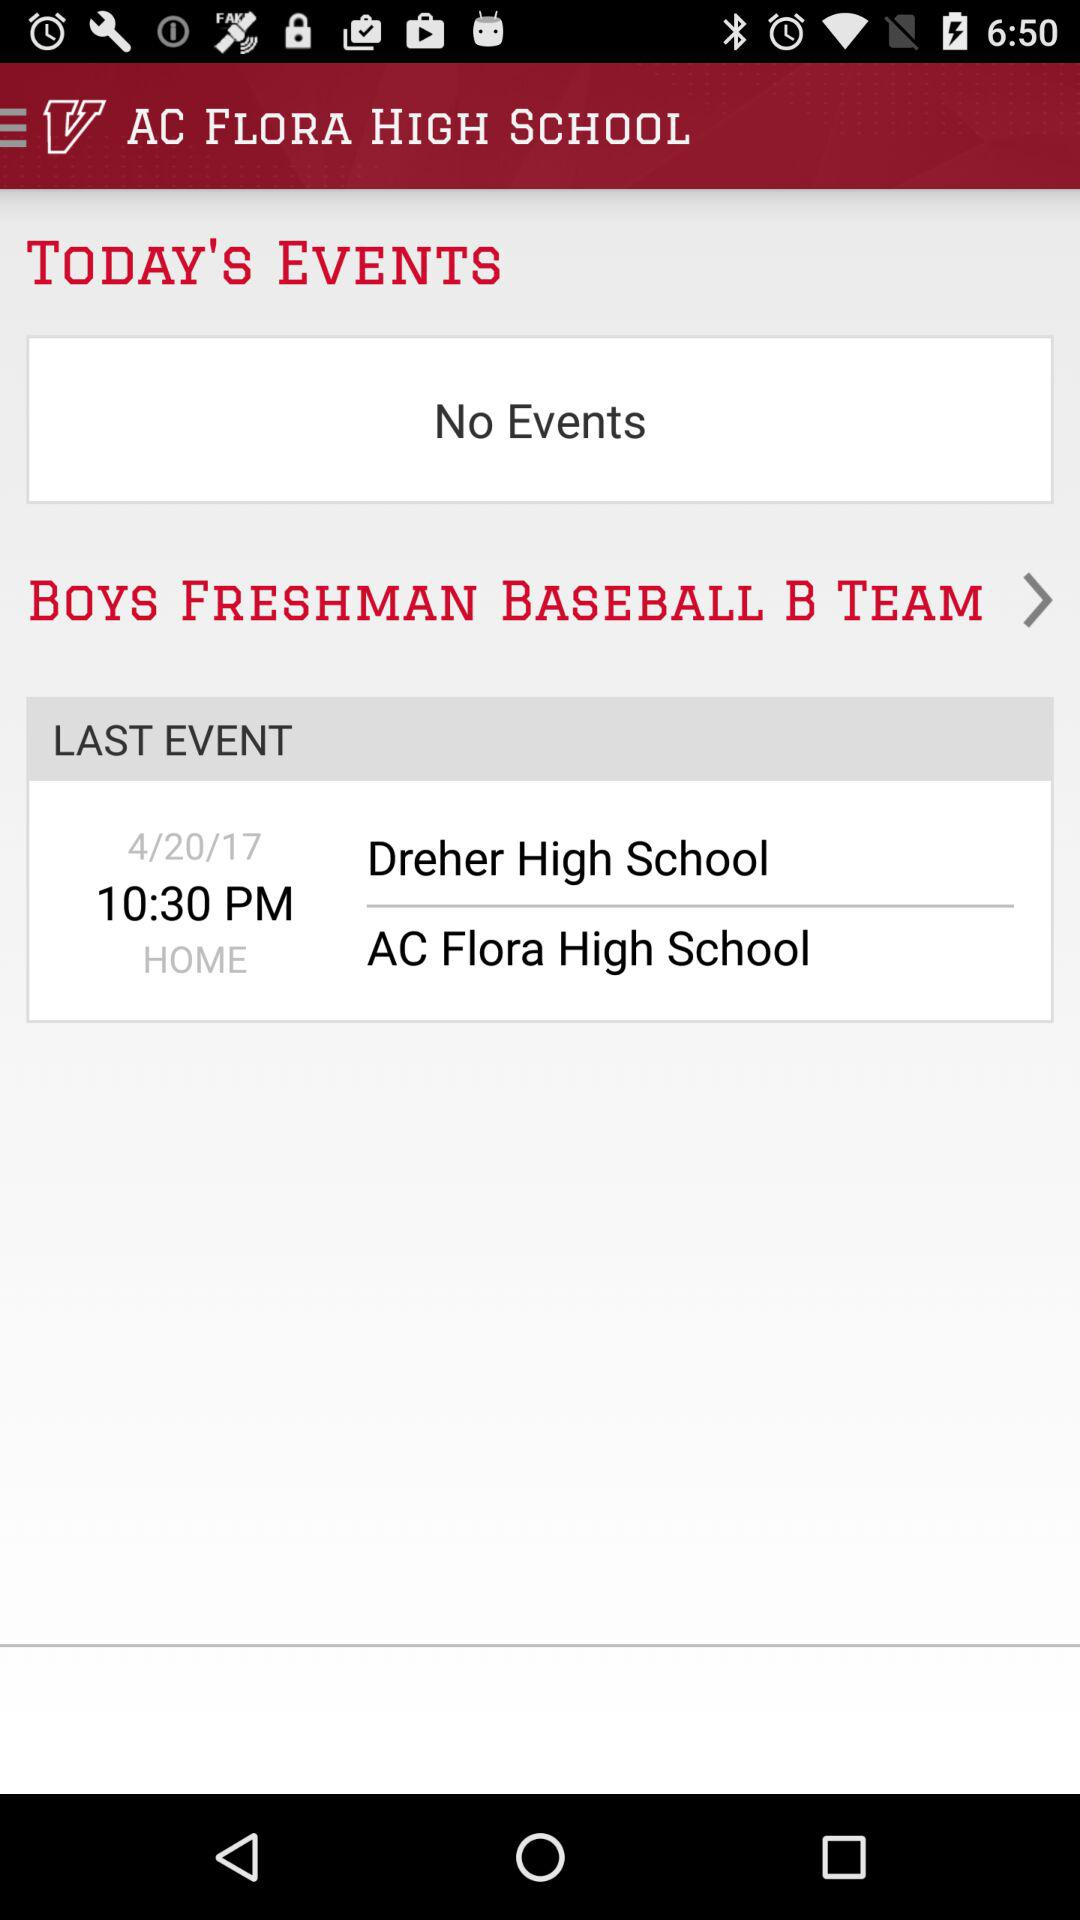At what time will the last event happen? The last event will happen at 10:30 pm. 